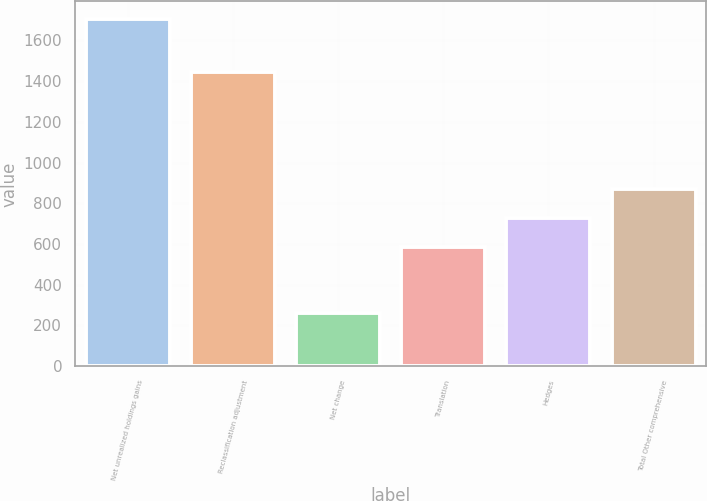Convert chart to OTSL. <chart><loc_0><loc_0><loc_500><loc_500><bar_chart><fcel>Net unrealized holdings gains<fcel>Reclassification adjustment<fcel>Net change<fcel>Translation<fcel>Hedges<fcel>Total Other comprehensive<nl><fcel>1706<fcel>1443<fcel>263<fcel>584<fcel>728.3<fcel>872.6<nl></chart> 